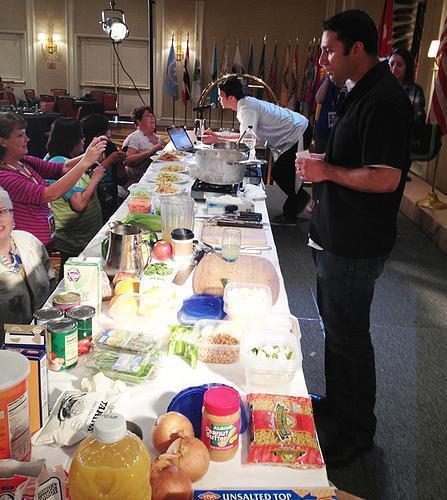How many people are on the left side of the table?
Give a very brief answer. 5. How many oranges are there?
Give a very brief answer. 3. How many people are taking picture?
Give a very brief answer. 1. 